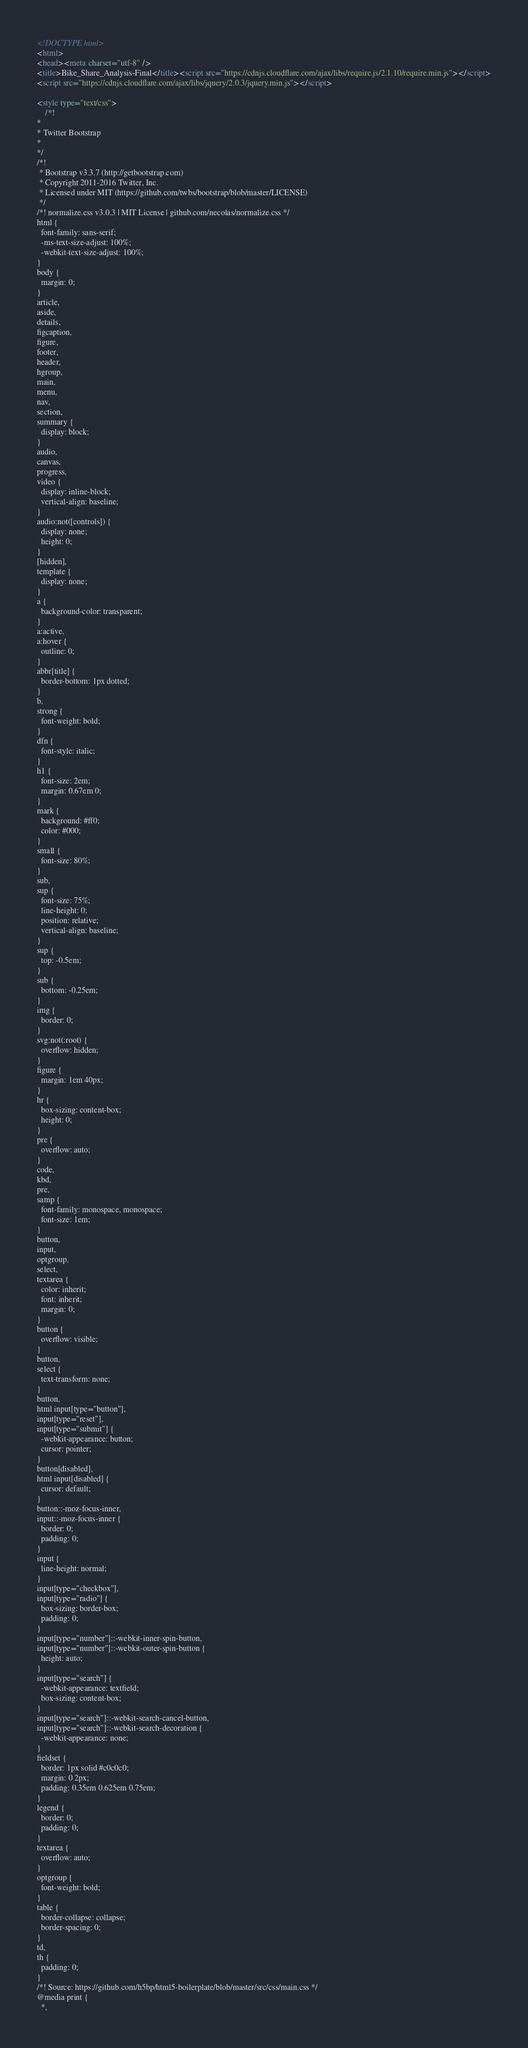<code> <loc_0><loc_0><loc_500><loc_500><_HTML_><!DOCTYPE html>
<html>
<head><meta charset="utf-8" />
<title>Bike_Share_Analysis-Final</title><script src="https://cdnjs.cloudflare.com/ajax/libs/require.js/2.1.10/require.min.js"></script>
<script src="https://cdnjs.cloudflare.com/ajax/libs/jquery/2.0.3/jquery.min.js"></script>

<style type="text/css">
    /*!
*
* Twitter Bootstrap
*
*/
/*!
 * Bootstrap v3.3.7 (http://getbootstrap.com)
 * Copyright 2011-2016 Twitter, Inc.
 * Licensed under MIT (https://github.com/twbs/bootstrap/blob/master/LICENSE)
 */
/*! normalize.css v3.0.3 | MIT License | github.com/necolas/normalize.css */
html {
  font-family: sans-serif;
  -ms-text-size-adjust: 100%;
  -webkit-text-size-adjust: 100%;
}
body {
  margin: 0;
}
article,
aside,
details,
figcaption,
figure,
footer,
header,
hgroup,
main,
menu,
nav,
section,
summary {
  display: block;
}
audio,
canvas,
progress,
video {
  display: inline-block;
  vertical-align: baseline;
}
audio:not([controls]) {
  display: none;
  height: 0;
}
[hidden],
template {
  display: none;
}
a {
  background-color: transparent;
}
a:active,
a:hover {
  outline: 0;
}
abbr[title] {
  border-bottom: 1px dotted;
}
b,
strong {
  font-weight: bold;
}
dfn {
  font-style: italic;
}
h1 {
  font-size: 2em;
  margin: 0.67em 0;
}
mark {
  background: #ff0;
  color: #000;
}
small {
  font-size: 80%;
}
sub,
sup {
  font-size: 75%;
  line-height: 0;
  position: relative;
  vertical-align: baseline;
}
sup {
  top: -0.5em;
}
sub {
  bottom: -0.25em;
}
img {
  border: 0;
}
svg:not(:root) {
  overflow: hidden;
}
figure {
  margin: 1em 40px;
}
hr {
  box-sizing: content-box;
  height: 0;
}
pre {
  overflow: auto;
}
code,
kbd,
pre,
samp {
  font-family: monospace, monospace;
  font-size: 1em;
}
button,
input,
optgroup,
select,
textarea {
  color: inherit;
  font: inherit;
  margin: 0;
}
button {
  overflow: visible;
}
button,
select {
  text-transform: none;
}
button,
html input[type="button"],
input[type="reset"],
input[type="submit"] {
  -webkit-appearance: button;
  cursor: pointer;
}
button[disabled],
html input[disabled] {
  cursor: default;
}
button::-moz-focus-inner,
input::-moz-focus-inner {
  border: 0;
  padding: 0;
}
input {
  line-height: normal;
}
input[type="checkbox"],
input[type="radio"] {
  box-sizing: border-box;
  padding: 0;
}
input[type="number"]::-webkit-inner-spin-button,
input[type="number"]::-webkit-outer-spin-button {
  height: auto;
}
input[type="search"] {
  -webkit-appearance: textfield;
  box-sizing: content-box;
}
input[type="search"]::-webkit-search-cancel-button,
input[type="search"]::-webkit-search-decoration {
  -webkit-appearance: none;
}
fieldset {
  border: 1px solid #c0c0c0;
  margin: 0 2px;
  padding: 0.35em 0.625em 0.75em;
}
legend {
  border: 0;
  padding: 0;
}
textarea {
  overflow: auto;
}
optgroup {
  font-weight: bold;
}
table {
  border-collapse: collapse;
  border-spacing: 0;
}
td,
th {
  padding: 0;
}
/*! Source: https://github.com/h5bp/html5-boilerplate/blob/master/src/css/main.css */
@media print {
  *,</code> 